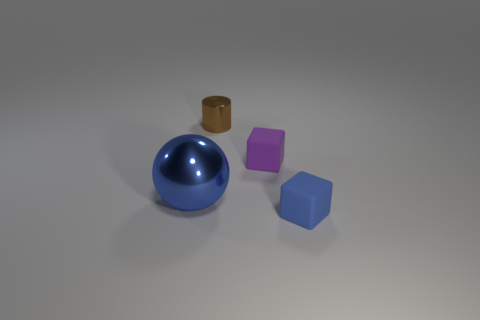What does the arrangement of these objects suggest to you? The arrangement of the objects gives a sense of deliberate placement for display or examination. There's a balance in the composition that could suggest a study of geometric shapes or an aesthetic presentation meant to highlight the differences in form and color. 